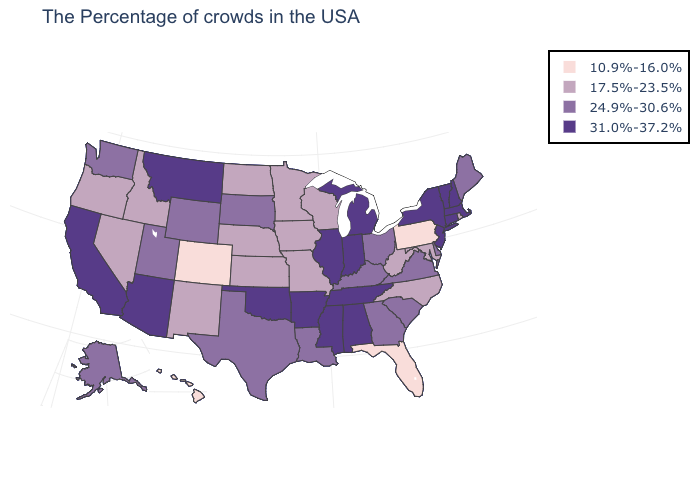Which states have the lowest value in the USA?
Be succinct. Pennsylvania, Florida, Colorado, Hawaii. What is the value of Maine?
Write a very short answer. 24.9%-30.6%. Name the states that have a value in the range 17.5%-23.5%?
Answer briefly. Rhode Island, Maryland, North Carolina, West Virginia, Wisconsin, Missouri, Minnesota, Iowa, Kansas, Nebraska, North Dakota, New Mexico, Idaho, Nevada, Oregon. What is the highest value in the USA?
Quick response, please. 31.0%-37.2%. Among the states that border North Dakota , does Montana have the highest value?
Be succinct. Yes. What is the value of Wyoming?
Concise answer only. 24.9%-30.6%. What is the highest value in the USA?
Concise answer only. 31.0%-37.2%. What is the value of Massachusetts?
Answer briefly. 31.0%-37.2%. What is the value of West Virginia?
Short answer required. 17.5%-23.5%. What is the value of Utah?
Concise answer only. 24.9%-30.6%. Does Wisconsin have the highest value in the MidWest?
Be succinct. No. What is the value of Utah?
Write a very short answer. 24.9%-30.6%. What is the value of Arkansas?
Keep it brief. 31.0%-37.2%. What is the lowest value in the Northeast?
Short answer required. 10.9%-16.0%. Does Alaska have the highest value in the West?
Be succinct. No. 